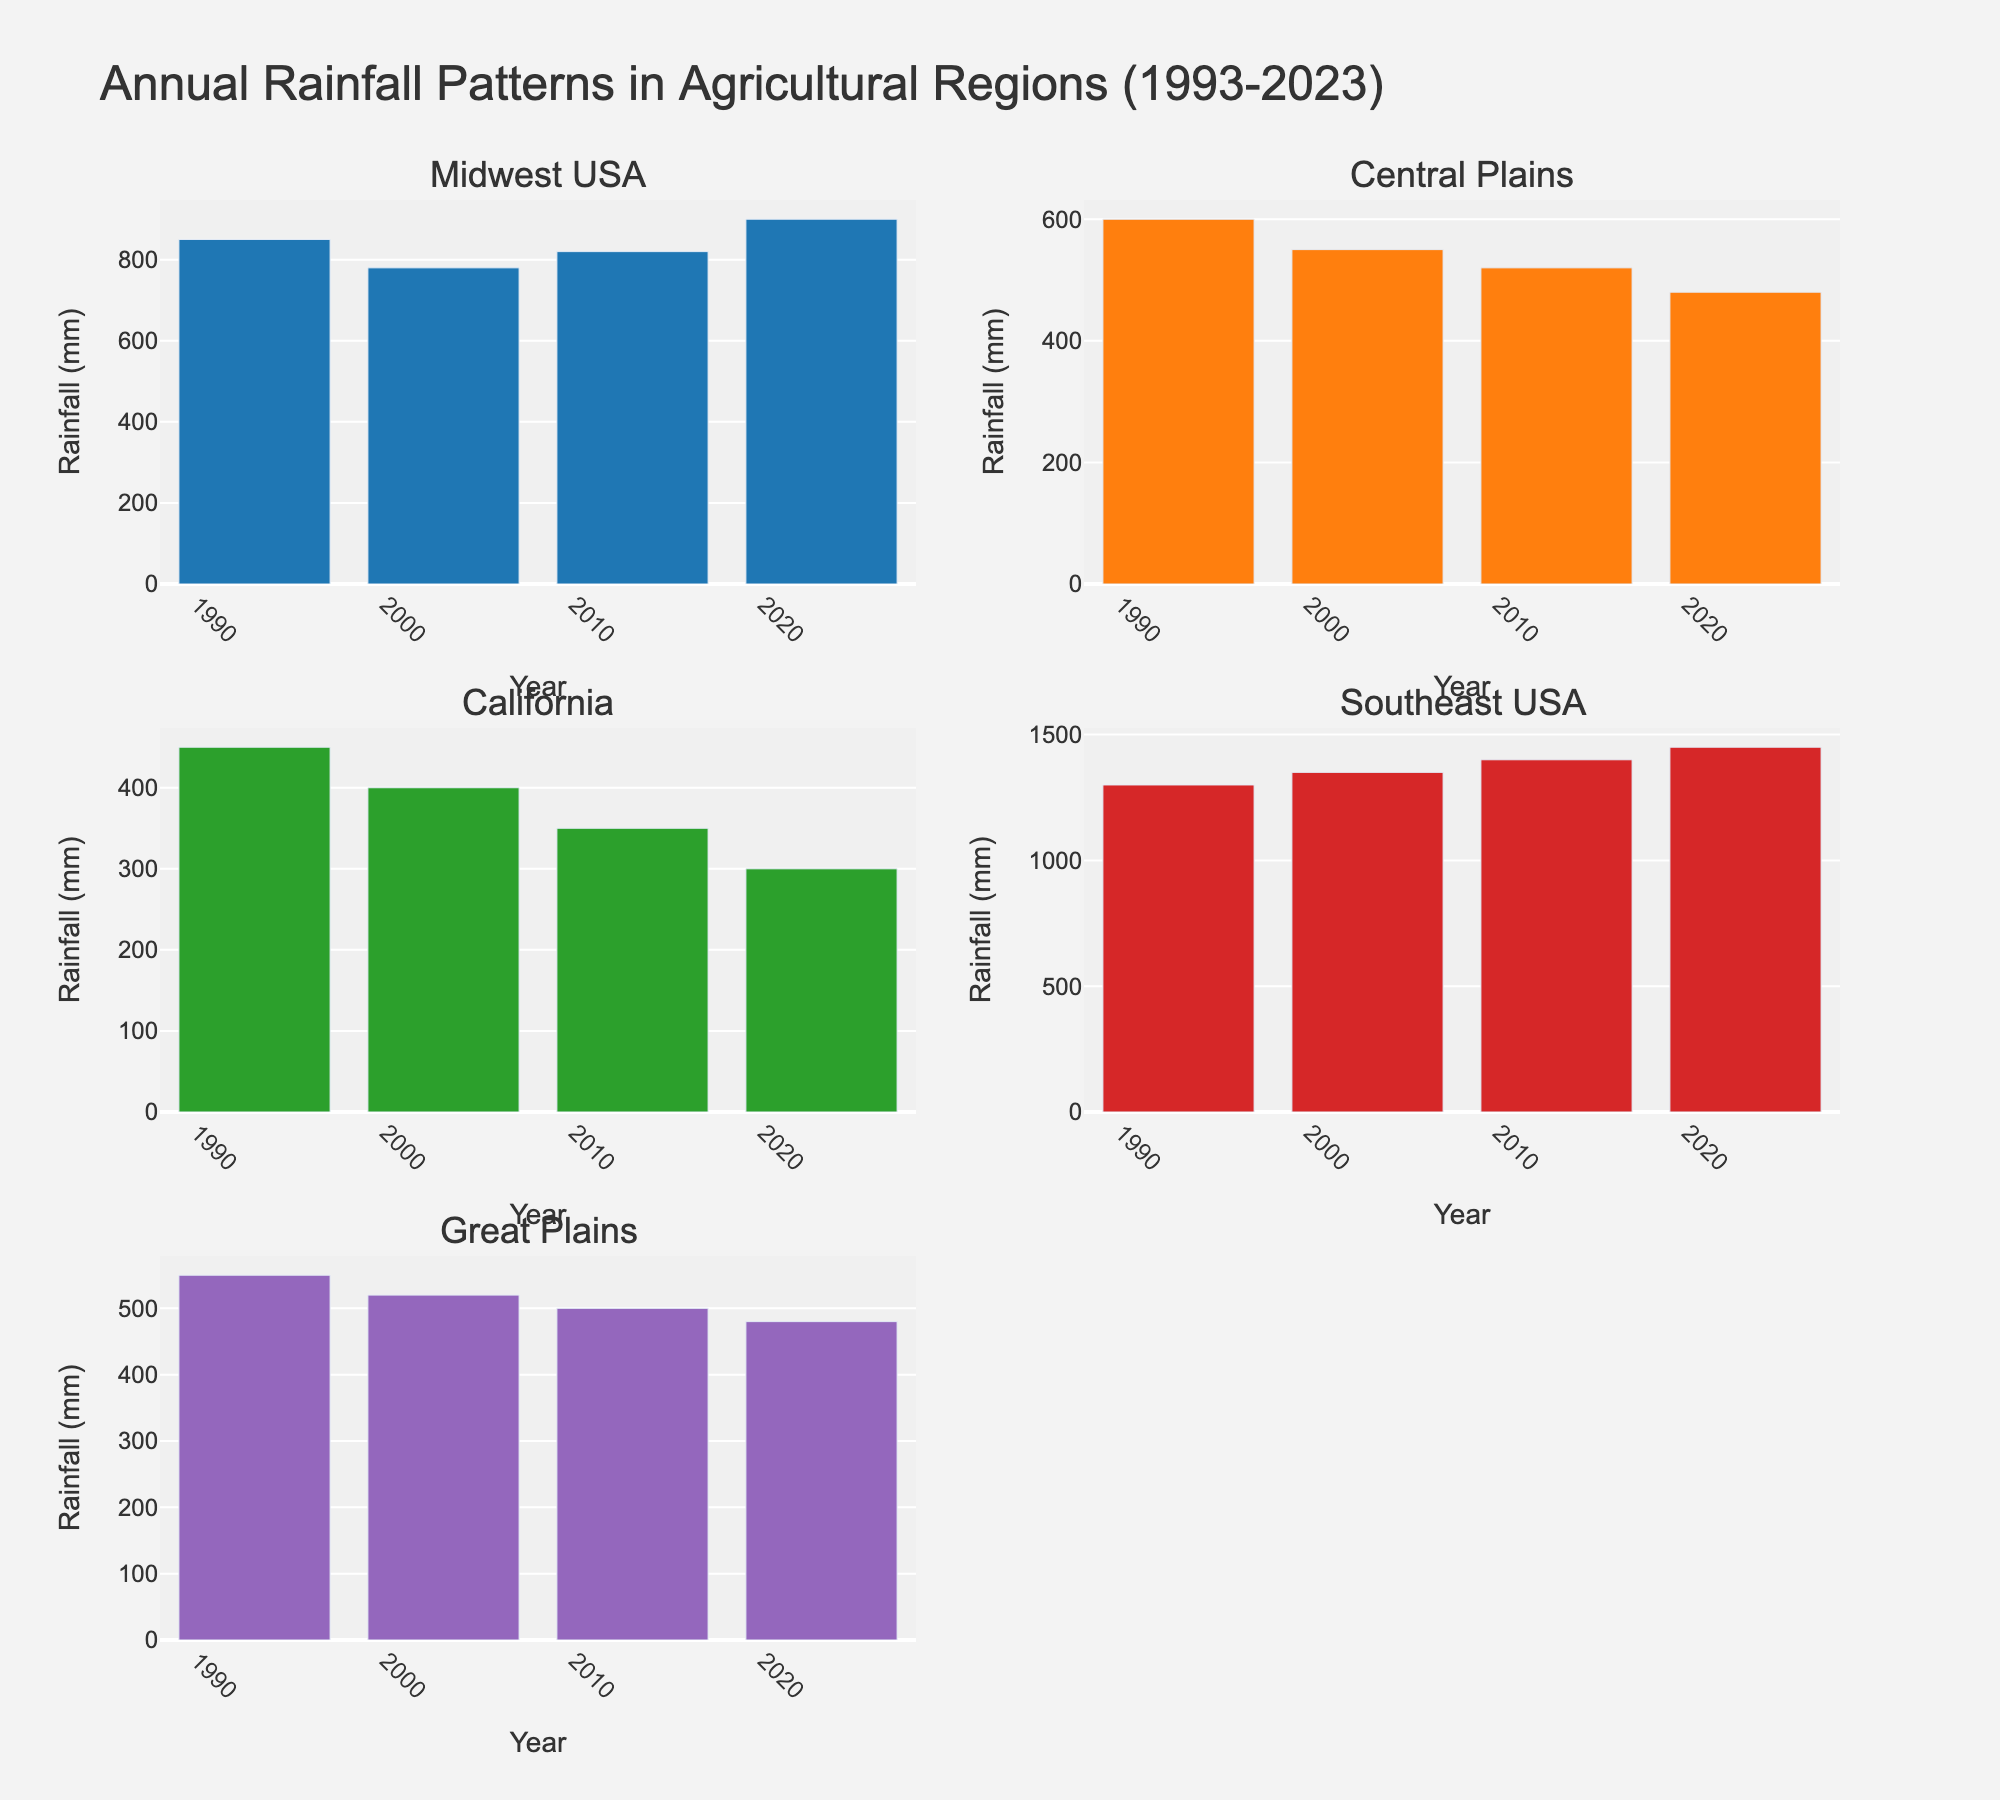What is the title of the figure? The title of the figure is usually placed at the top, and it summarizes the main idea of the figure. Here, the title is "Annual Rainfall Patterns in Agricultural Regions (1993-2023)".
Answer: Annual Rainfall Patterns in Agricultural Regions (1993-2023) How many regions are shown in the subplots? To determine the number of regions, count the number of subplot titles. There are six regions depicted, as noted by the subplot titles.
Answer: Six Which region had the highest rainfall in 2023? To find this, locate the bar representing 2023 in each subplot and identify the region with the tallest bar. The Southeast USA has the highest rainfall in 2023 with a value of 1450 mm.
Answer: Southeast USA Compare the rainfall trends of Midwest USA and California from 1993 to 2023. To compare trends, observe the changes in the bars from 1993 to 2023 in the Midwest USA and California subplots. Midwest USA shows a general increase in rainfall, while California exhibits a consistent decrease.
Answer: Midwest USA: Increase, California: Decrease Which region shows the most significant decrease in rainfall from 1993 to 2023? Identify the longest downward trend by comparing the bars from 1993 to 2023 across all subplots. California's rainfall decreased from 450 mm in 1993 to 300 mm in 2023.
Answer: California Calculate the total rainfall accumulated in the Southeast USA from 1993 to 2023. Sum the bar values in the Southeast USA subplot: 1300 mm (1993) + 1350 mm (2003) + 1400 mm (2013) + 1450 mm (2023) = 5500 mm.
Answer: 5500 mm What is the average annual rainfall in the Central Plains over the 30 years? Average can be found by summing the values and then dividing by the number of data points. (600 + 550 + 520 + 480) / 4 = 2150 / 4 = 537.5 mm.
Answer: 537.5 mm How does the 2023 rainfall in the Great Plains compare to that in the Central Plains? Compare the height of the 2023 bars in the Great Plains and Central Plains subplots. Both regions have the same rainfall of 480 mm in 2023.
Answer: They are equal What is the trend in rainfall for the Great Plains from 1993 to 2023? Observe the sequence of bars from 1993 to 2023 in the Great Plains subplot. The trend shows a consistent decrease in rainfall from 550 mm to 480 mm.
Answer: Decreasing Which year had the highest overall rainfall across all regions? Add the rainfall values for each year across all regions and identify the year with the highest total sum: 
1993: 850 + 600 + 450 + 1300 + 550 = 3750 mm
2003: 780 + 550 + 400 + 1350 + 520 = 3600 mm
2013: 820 + 520 + 350 + 1400 + 500 = 3590 mm
2023: 900 + 480 + 300 + 1450 + 480 = 3610 mm
1993 has the highest overall rainfall.
Answer: 1993 